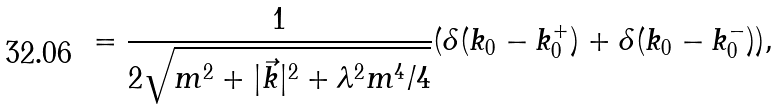<formula> <loc_0><loc_0><loc_500><loc_500>= \frac { 1 } { 2 \sqrt { m ^ { 2 } + | \vec { k } | ^ { 2 } + \lambda ^ { 2 } m ^ { 4 } / 4 } } ( \delta ( k _ { 0 } - k ^ { + } _ { 0 } ) + \delta ( k _ { 0 } - k ^ { - } _ { 0 } ) ) ,</formula> 